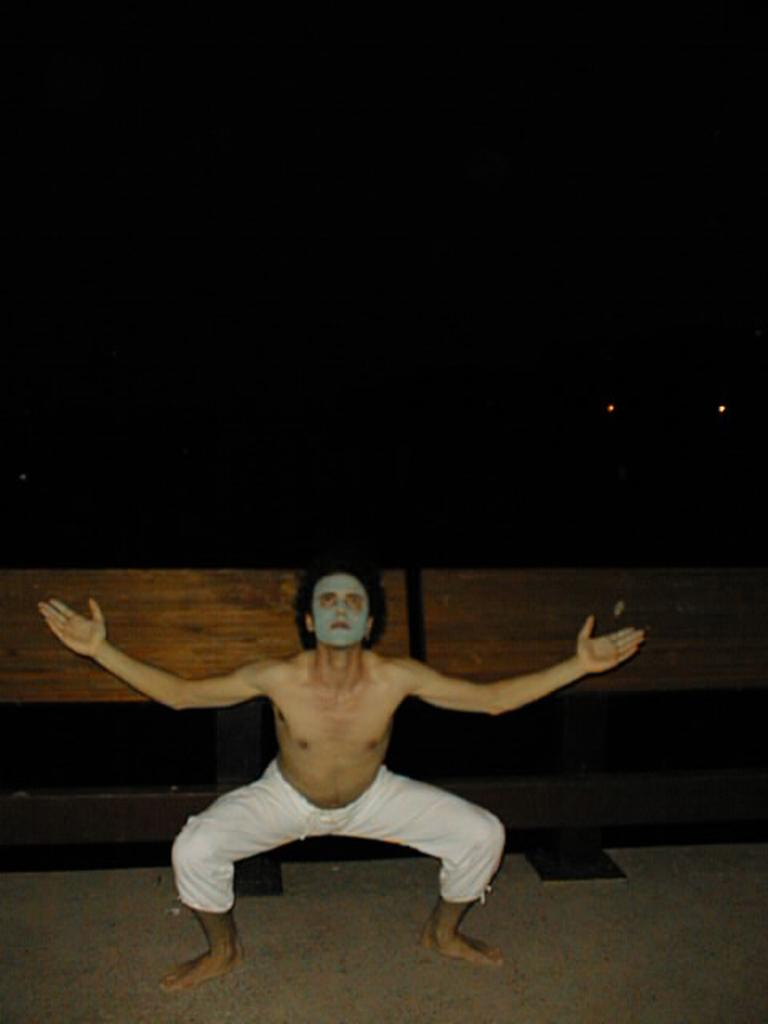What is the person in the image doing? There is a person squatting in the image. What can be seen behind the person? There is a railing at the back of the image. What can be seen illuminating the area in the image? There are lights in the image. What is visible at the top of the image? The sky is visible at the top of the image. What is the surface that the person is standing on? There is a floor at the bottom of the image. Is there a water fountain in the image to celebrate the person's birthday? There is no water fountain or reference to a birthday in the image. 